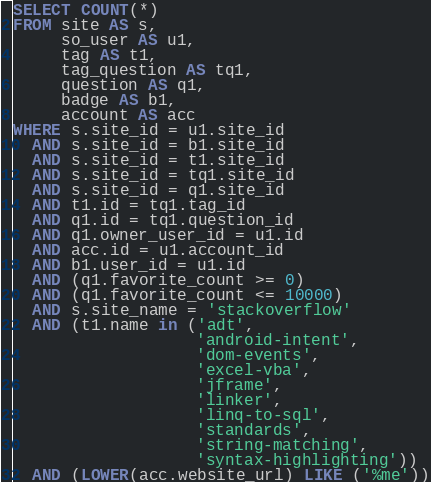Convert code to text. <code><loc_0><loc_0><loc_500><loc_500><_SQL_>SELECT COUNT(*)
FROM site AS s,
     so_user AS u1,
     tag AS t1,
     tag_question AS tq1,
     question AS q1,
     badge AS b1,
     account AS acc
WHERE s.site_id = u1.site_id
  AND s.site_id = b1.site_id
  AND s.site_id = t1.site_id
  AND s.site_id = tq1.site_id
  AND s.site_id = q1.site_id
  AND t1.id = tq1.tag_id
  AND q1.id = tq1.question_id
  AND q1.owner_user_id = u1.id
  AND acc.id = u1.account_id
  AND b1.user_id = u1.id
  AND (q1.favorite_count >= 0)
  AND (q1.favorite_count <= 10000)
  AND s.site_name = 'stackoverflow'
  AND (t1.name in ('adt',
                   'android-intent',
                   'dom-events',
                   'excel-vba',
                   'jframe',
                   'linker',
                   'linq-to-sql',
                   'standards',
                   'string-matching',
                   'syntax-highlighting'))
  AND (LOWER(acc.website_url) LIKE ('%me'))</code> 